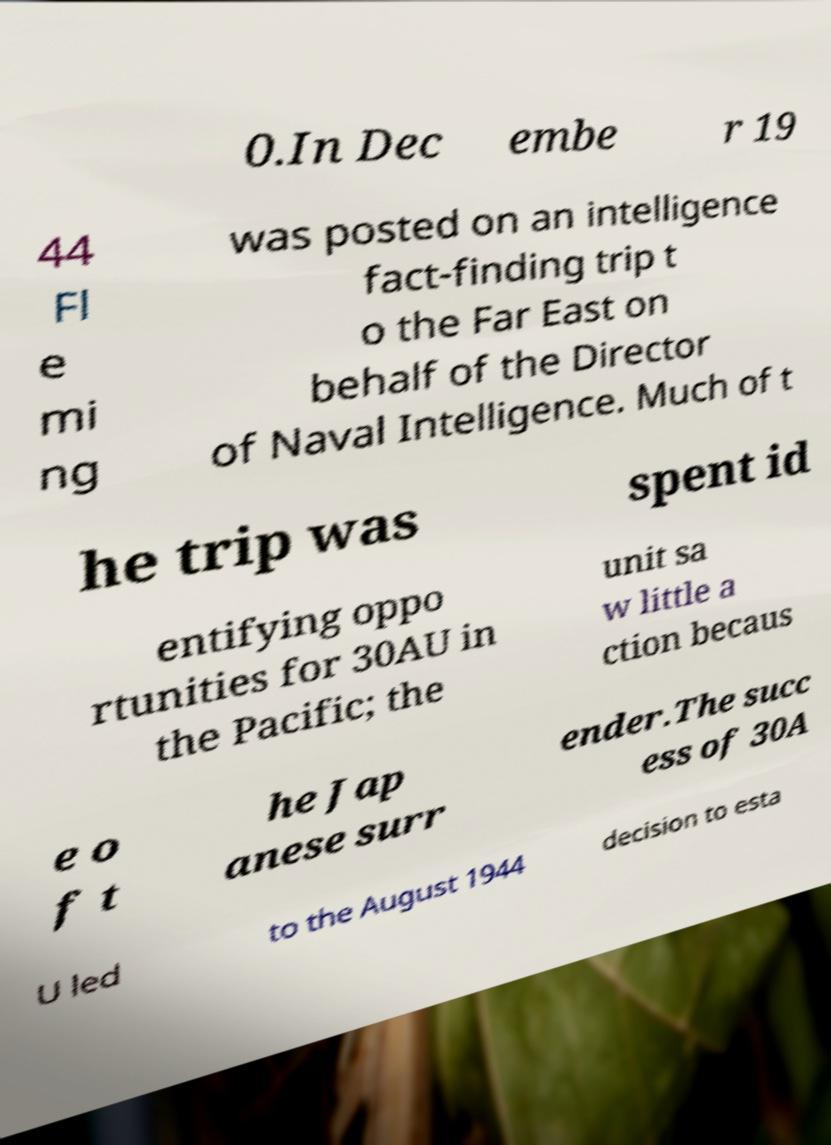Could you extract and type out the text from this image? 0.In Dec embe r 19 44 Fl e mi ng was posted on an intelligence fact-finding trip t o the Far East on behalf of the Director of Naval Intelligence. Much of t he trip was spent id entifying oppo rtunities for 30AU in the Pacific; the unit sa w little a ction becaus e o f t he Jap anese surr ender.The succ ess of 30A U led to the August 1944 decision to esta 